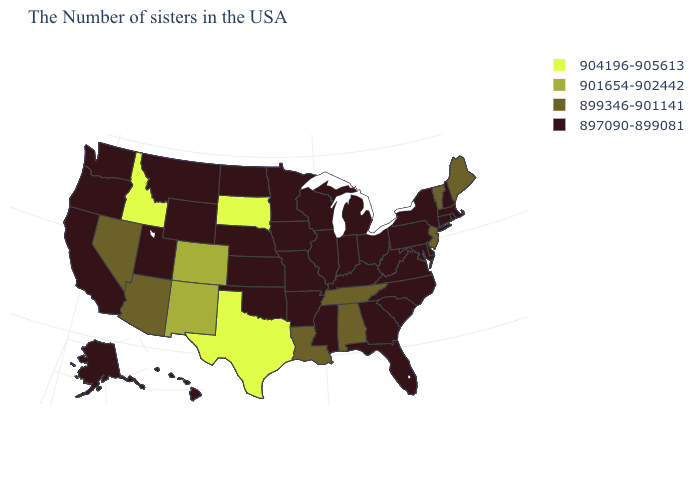What is the value of North Carolina?
Keep it brief. 897090-899081. Does the first symbol in the legend represent the smallest category?
Write a very short answer. No. What is the value of Utah?
Write a very short answer. 897090-899081. What is the value of Idaho?
Concise answer only. 904196-905613. Which states have the highest value in the USA?
Keep it brief. Texas, South Dakota, Idaho. What is the lowest value in states that border Missouri?
Give a very brief answer. 897090-899081. Name the states that have a value in the range 899346-901141?
Short answer required. Maine, Vermont, New Jersey, Alabama, Tennessee, Louisiana, Arizona, Nevada. Which states hav the highest value in the West?
Be succinct. Idaho. Name the states that have a value in the range 897090-899081?
Write a very short answer. Massachusetts, Rhode Island, New Hampshire, Connecticut, New York, Delaware, Maryland, Pennsylvania, Virginia, North Carolina, South Carolina, West Virginia, Ohio, Florida, Georgia, Michigan, Kentucky, Indiana, Wisconsin, Illinois, Mississippi, Missouri, Arkansas, Minnesota, Iowa, Kansas, Nebraska, Oklahoma, North Dakota, Wyoming, Utah, Montana, California, Washington, Oregon, Alaska, Hawaii. Name the states that have a value in the range 904196-905613?
Give a very brief answer. Texas, South Dakota, Idaho. What is the lowest value in the South?
Short answer required. 897090-899081. Name the states that have a value in the range 899346-901141?
Answer briefly. Maine, Vermont, New Jersey, Alabama, Tennessee, Louisiana, Arizona, Nevada. What is the value of New Mexico?
Answer briefly. 901654-902442. How many symbols are there in the legend?
Keep it brief. 4. 